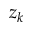Convert formula to latex. <formula><loc_0><loc_0><loc_500><loc_500>z _ { k }</formula> 